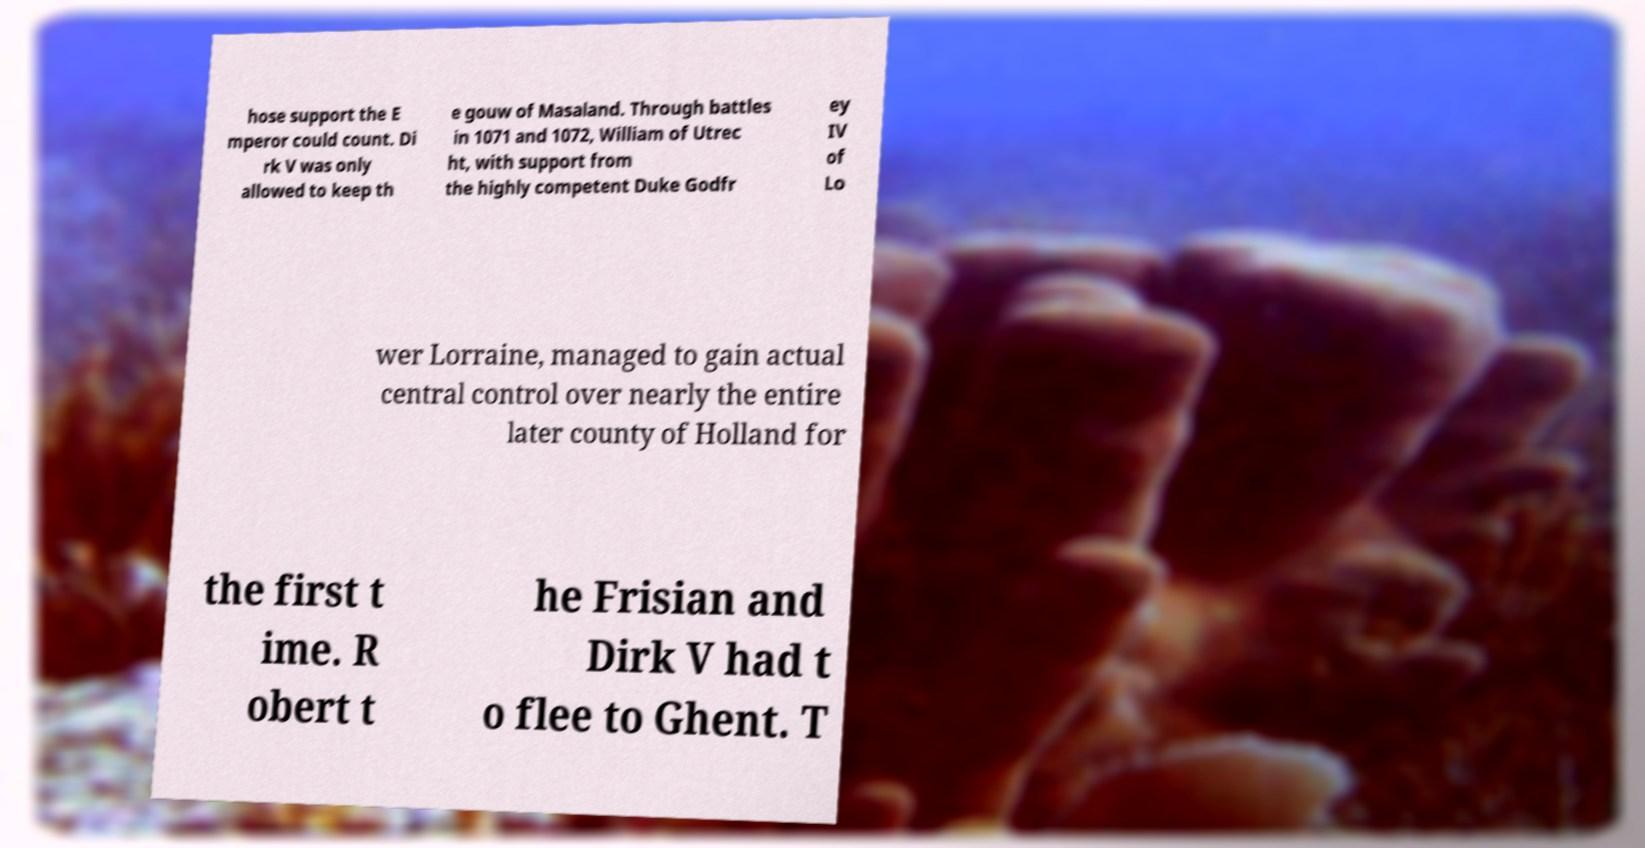What messages or text are displayed in this image? I need them in a readable, typed format. hose support the E mperor could count. Di rk V was only allowed to keep th e gouw of Masaland. Through battles in 1071 and 1072, William of Utrec ht, with support from the highly competent Duke Godfr ey IV of Lo wer Lorraine, managed to gain actual central control over nearly the entire later county of Holland for the first t ime. R obert t he Frisian and Dirk V had t o flee to Ghent. T 